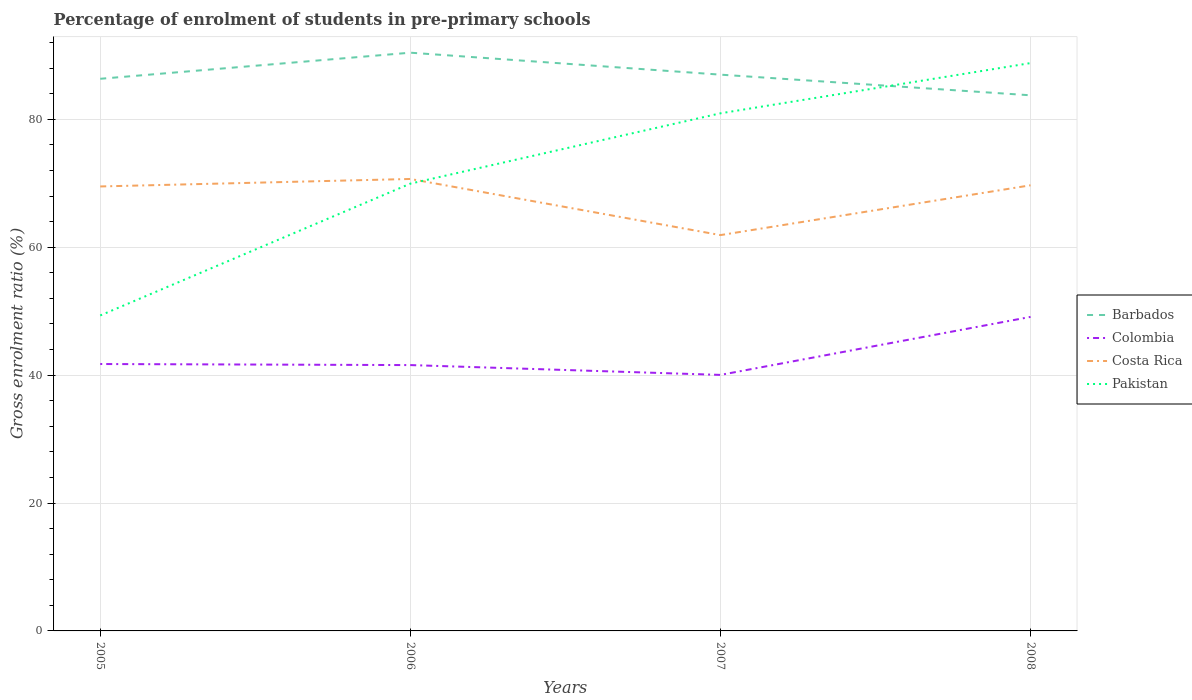Does the line corresponding to Barbados intersect with the line corresponding to Colombia?
Your answer should be compact. No. Across all years, what is the maximum percentage of students enrolled in pre-primary schools in Pakistan?
Ensure brevity in your answer.  49.33. In which year was the percentage of students enrolled in pre-primary schools in Barbados maximum?
Offer a very short reply. 2008. What is the total percentage of students enrolled in pre-primary schools in Costa Rica in the graph?
Offer a very short reply. 0.99. What is the difference between the highest and the second highest percentage of students enrolled in pre-primary schools in Costa Rica?
Offer a very short reply. 8.78. How many lines are there?
Give a very brief answer. 4. How many years are there in the graph?
Provide a short and direct response. 4. Does the graph contain any zero values?
Ensure brevity in your answer.  No. How many legend labels are there?
Provide a short and direct response. 4. How are the legend labels stacked?
Your answer should be compact. Vertical. What is the title of the graph?
Your response must be concise. Percentage of enrolment of students in pre-primary schools. What is the label or title of the X-axis?
Keep it short and to the point. Years. What is the label or title of the Y-axis?
Offer a terse response. Gross enrolment ratio (%). What is the Gross enrolment ratio (%) in Barbados in 2005?
Your answer should be compact. 86.34. What is the Gross enrolment ratio (%) of Colombia in 2005?
Make the answer very short. 41.74. What is the Gross enrolment ratio (%) in Costa Rica in 2005?
Make the answer very short. 69.51. What is the Gross enrolment ratio (%) in Pakistan in 2005?
Make the answer very short. 49.33. What is the Gross enrolment ratio (%) in Barbados in 2006?
Make the answer very short. 90.42. What is the Gross enrolment ratio (%) in Colombia in 2006?
Offer a very short reply. 41.57. What is the Gross enrolment ratio (%) of Costa Rica in 2006?
Offer a terse response. 70.68. What is the Gross enrolment ratio (%) in Pakistan in 2006?
Keep it short and to the point. 69.95. What is the Gross enrolment ratio (%) in Barbados in 2007?
Offer a terse response. 86.99. What is the Gross enrolment ratio (%) in Colombia in 2007?
Ensure brevity in your answer.  40.04. What is the Gross enrolment ratio (%) of Costa Rica in 2007?
Your answer should be compact. 61.9. What is the Gross enrolment ratio (%) of Pakistan in 2007?
Offer a very short reply. 80.94. What is the Gross enrolment ratio (%) in Barbados in 2008?
Offer a very short reply. 83.76. What is the Gross enrolment ratio (%) of Colombia in 2008?
Give a very brief answer. 49.11. What is the Gross enrolment ratio (%) in Costa Rica in 2008?
Offer a terse response. 69.69. What is the Gross enrolment ratio (%) of Pakistan in 2008?
Keep it short and to the point. 88.8. Across all years, what is the maximum Gross enrolment ratio (%) in Barbados?
Offer a very short reply. 90.42. Across all years, what is the maximum Gross enrolment ratio (%) of Colombia?
Your response must be concise. 49.11. Across all years, what is the maximum Gross enrolment ratio (%) of Costa Rica?
Make the answer very short. 70.68. Across all years, what is the maximum Gross enrolment ratio (%) of Pakistan?
Offer a very short reply. 88.8. Across all years, what is the minimum Gross enrolment ratio (%) of Barbados?
Ensure brevity in your answer.  83.76. Across all years, what is the minimum Gross enrolment ratio (%) of Colombia?
Your answer should be very brief. 40.04. Across all years, what is the minimum Gross enrolment ratio (%) in Costa Rica?
Give a very brief answer. 61.9. Across all years, what is the minimum Gross enrolment ratio (%) of Pakistan?
Give a very brief answer. 49.33. What is the total Gross enrolment ratio (%) in Barbados in the graph?
Keep it short and to the point. 347.51. What is the total Gross enrolment ratio (%) of Colombia in the graph?
Your response must be concise. 172.45. What is the total Gross enrolment ratio (%) in Costa Rica in the graph?
Offer a terse response. 271.77. What is the total Gross enrolment ratio (%) of Pakistan in the graph?
Provide a short and direct response. 289.02. What is the difference between the Gross enrolment ratio (%) of Barbados in 2005 and that in 2006?
Your answer should be very brief. -4.08. What is the difference between the Gross enrolment ratio (%) of Colombia in 2005 and that in 2006?
Keep it short and to the point. 0.17. What is the difference between the Gross enrolment ratio (%) of Costa Rica in 2005 and that in 2006?
Keep it short and to the point. -1.17. What is the difference between the Gross enrolment ratio (%) in Pakistan in 2005 and that in 2006?
Your response must be concise. -20.62. What is the difference between the Gross enrolment ratio (%) of Barbados in 2005 and that in 2007?
Offer a very short reply. -0.65. What is the difference between the Gross enrolment ratio (%) in Colombia in 2005 and that in 2007?
Give a very brief answer. 1.7. What is the difference between the Gross enrolment ratio (%) in Costa Rica in 2005 and that in 2007?
Give a very brief answer. 7.61. What is the difference between the Gross enrolment ratio (%) of Pakistan in 2005 and that in 2007?
Offer a terse response. -31.61. What is the difference between the Gross enrolment ratio (%) of Barbados in 2005 and that in 2008?
Ensure brevity in your answer.  2.58. What is the difference between the Gross enrolment ratio (%) in Colombia in 2005 and that in 2008?
Ensure brevity in your answer.  -7.37. What is the difference between the Gross enrolment ratio (%) in Costa Rica in 2005 and that in 2008?
Provide a succinct answer. -0.18. What is the difference between the Gross enrolment ratio (%) of Pakistan in 2005 and that in 2008?
Offer a very short reply. -39.47. What is the difference between the Gross enrolment ratio (%) in Barbados in 2006 and that in 2007?
Make the answer very short. 3.43. What is the difference between the Gross enrolment ratio (%) of Colombia in 2006 and that in 2007?
Provide a short and direct response. 1.54. What is the difference between the Gross enrolment ratio (%) of Costa Rica in 2006 and that in 2007?
Your response must be concise. 8.78. What is the difference between the Gross enrolment ratio (%) in Pakistan in 2006 and that in 2007?
Give a very brief answer. -11. What is the difference between the Gross enrolment ratio (%) of Barbados in 2006 and that in 2008?
Make the answer very short. 6.66. What is the difference between the Gross enrolment ratio (%) in Colombia in 2006 and that in 2008?
Provide a succinct answer. -7.54. What is the difference between the Gross enrolment ratio (%) of Costa Rica in 2006 and that in 2008?
Your answer should be very brief. 0.99. What is the difference between the Gross enrolment ratio (%) in Pakistan in 2006 and that in 2008?
Give a very brief answer. -18.85. What is the difference between the Gross enrolment ratio (%) in Barbados in 2007 and that in 2008?
Give a very brief answer. 3.23. What is the difference between the Gross enrolment ratio (%) in Colombia in 2007 and that in 2008?
Your answer should be very brief. -9.07. What is the difference between the Gross enrolment ratio (%) in Costa Rica in 2007 and that in 2008?
Make the answer very short. -7.79. What is the difference between the Gross enrolment ratio (%) in Pakistan in 2007 and that in 2008?
Your answer should be very brief. -7.86. What is the difference between the Gross enrolment ratio (%) in Barbados in 2005 and the Gross enrolment ratio (%) in Colombia in 2006?
Provide a short and direct response. 44.77. What is the difference between the Gross enrolment ratio (%) of Barbados in 2005 and the Gross enrolment ratio (%) of Costa Rica in 2006?
Offer a terse response. 15.67. What is the difference between the Gross enrolment ratio (%) in Barbados in 2005 and the Gross enrolment ratio (%) in Pakistan in 2006?
Offer a very short reply. 16.4. What is the difference between the Gross enrolment ratio (%) in Colombia in 2005 and the Gross enrolment ratio (%) in Costa Rica in 2006?
Offer a terse response. -28.94. What is the difference between the Gross enrolment ratio (%) in Colombia in 2005 and the Gross enrolment ratio (%) in Pakistan in 2006?
Make the answer very short. -28.21. What is the difference between the Gross enrolment ratio (%) of Costa Rica in 2005 and the Gross enrolment ratio (%) of Pakistan in 2006?
Your answer should be compact. -0.44. What is the difference between the Gross enrolment ratio (%) in Barbados in 2005 and the Gross enrolment ratio (%) in Colombia in 2007?
Provide a succinct answer. 46.31. What is the difference between the Gross enrolment ratio (%) in Barbados in 2005 and the Gross enrolment ratio (%) in Costa Rica in 2007?
Provide a short and direct response. 24.44. What is the difference between the Gross enrolment ratio (%) of Barbados in 2005 and the Gross enrolment ratio (%) of Pakistan in 2007?
Your answer should be very brief. 5.4. What is the difference between the Gross enrolment ratio (%) in Colombia in 2005 and the Gross enrolment ratio (%) in Costa Rica in 2007?
Offer a terse response. -20.16. What is the difference between the Gross enrolment ratio (%) in Colombia in 2005 and the Gross enrolment ratio (%) in Pakistan in 2007?
Offer a very short reply. -39.2. What is the difference between the Gross enrolment ratio (%) in Costa Rica in 2005 and the Gross enrolment ratio (%) in Pakistan in 2007?
Ensure brevity in your answer.  -11.44. What is the difference between the Gross enrolment ratio (%) in Barbados in 2005 and the Gross enrolment ratio (%) in Colombia in 2008?
Your response must be concise. 37.24. What is the difference between the Gross enrolment ratio (%) in Barbados in 2005 and the Gross enrolment ratio (%) in Costa Rica in 2008?
Your answer should be very brief. 16.65. What is the difference between the Gross enrolment ratio (%) of Barbados in 2005 and the Gross enrolment ratio (%) of Pakistan in 2008?
Keep it short and to the point. -2.46. What is the difference between the Gross enrolment ratio (%) of Colombia in 2005 and the Gross enrolment ratio (%) of Costa Rica in 2008?
Offer a terse response. -27.95. What is the difference between the Gross enrolment ratio (%) in Colombia in 2005 and the Gross enrolment ratio (%) in Pakistan in 2008?
Offer a very short reply. -47.06. What is the difference between the Gross enrolment ratio (%) of Costa Rica in 2005 and the Gross enrolment ratio (%) of Pakistan in 2008?
Your response must be concise. -19.29. What is the difference between the Gross enrolment ratio (%) in Barbados in 2006 and the Gross enrolment ratio (%) in Colombia in 2007?
Offer a terse response. 50.39. What is the difference between the Gross enrolment ratio (%) in Barbados in 2006 and the Gross enrolment ratio (%) in Costa Rica in 2007?
Keep it short and to the point. 28.52. What is the difference between the Gross enrolment ratio (%) of Barbados in 2006 and the Gross enrolment ratio (%) of Pakistan in 2007?
Offer a terse response. 9.48. What is the difference between the Gross enrolment ratio (%) in Colombia in 2006 and the Gross enrolment ratio (%) in Costa Rica in 2007?
Keep it short and to the point. -20.33. What is the difference between the Gross enrolment ratio (%) of Colombia in 2006 and the Gross enrolment ratio (%) of Pakistan in 2007?
Provide a succinct answer. -39.37. What is the difference between the Gross enrolment ratio (%) in Costa Rica in 2006 and the Gross enrolment ratio (%) in Pakistan in 2007?
Provide a succinct answer. -10.27. What is the difference between the Gross enrolment ratio (%) of Barbados in 2006 and the Gross enrolment ratio (%) of Colombia in 2008?
Provide a short and direct response. 41.32. What is the difference between the Gross enrolment ratio (%) in Barbados in 2006 and the Gross enrolment ratio (%) in Costa Rica in 2008?
Give a very brief answer. 20.74. What is the difference between the Gross enrolment ratio (%) in Barbados in 2006 and the Gross enrolment ratio (%) in Pakistan in 2008?
Your answer should be very brief. 1.63. What is the difference between the Gross enrolment ratio (%) of Colombia in 2006 and the Gross enrolment ratio (%) of Costa Rica in 2008?
Your answer should be compact. -28.12. What is the difference between the Gross enrolment ratio (%) of Colombia in 2006 and the Gross enrolment ratio (%) of Pakistan in 2008?
Your answer should be compact. -47.23. What is the difference between the Gross enrolment ratio (%) in Costa Rica in 2006 and the Gross enrolment ratio (%) in Pakistan in 2008?
Your answer should be compact. -18.12. What is the difference between the Gross enrolment ratio (%) in Barbados in 2007 and the Gross enrolment ratio (%) in Colombia in 2008?
Provide a succinct answer. 37.88. What is the difference between the Gross enrolment ratio (%) in Barbados in 2007 and the Gross enrolment ratio (%) in Costa Rica in 2008?
Your answer should be compact. 17.3. What is the difference between the Gross enrolment ratio (%) of Barbados in 2007 and the Gross enrolment ratio (%) of Pakistan in 2008?
Your answer should be compact. -1.81. What is the difference between the Gross enrolment ratio (%) in Colombia in 2007 and the Gross enrolment ratio (%) in Costa Rica in 2008?
Keep it short and to the point. -29.65. What is the difference between the Gross enrolment ratio (%) in Colombia in 2007 and the Gross enrolment ratio (%) in Pakistan in 2008?
Your answer should be compact. -48.76. What is the difference between the Gross enrolment ratio (%) of Costa Rica in 2007 and the Gross enrolment ratio (%) of Pakistan in 2008?
Provide a succinct answer. -26.9. What is the average Gross enrolment ratio (%) in Barbados per year?
Provide a succinct answer. 86.88. What is the average Gross enrolment ratio (%) in Colombia per year?
Your answer should be very brief. 43.11. What is the average Gross enrolment ratio (%) of Costa Rica per year?
Your response must be concise. 67.94. What is the average Gross enrolment ratio (%) in Pakistan per year?
Provide a short and direct response. 72.25. In the year 2005, what is the difference between the Gross enrolment ratio (%) in Barbados and Gross enrolment ratio (%) in Colombia?
Make the answer very short. 44.6. In the year 2005, what is the difference between the Gross enrolment ratio (%) of Barbados and Gross enrolment ratio (%) of Costa Rica?
Your answer should be very brief. 16.84. In the year 2005, what is the difference between the Gross enrolment ratio (%) of Barbados and Gross enrolment ratio (%) of Pakistan?
Offer a very short reply. 37.01. In the year 2005, what is the difference between the Gross enrolment ratio (%) in Colombia and Gross enrolment ratio (%) in Costa Rica?
Keep it short and to the point. -27.77. In the year 2005, what is the difference between the Gross enrolment ratio (%) of Colombia and Gross enrolment ratio (%) of Pakistan?
Ensure brevity in your answer.  -7.59. In the year 2005, what is the difference between the Gross enrolment ratio (%) in Costa Rica and Gross enrolment ratio (%) in Pakistan?
Give a very brief answer. 20.18. In the year 2006, what is the difference between the Gross enrolment ratio (%) of Barbados and Gross enrolment ratio (%) of Colombia?
Provide a short and direct response. 48.85. In the year 2006, what is the difference between the Gross enrolment ratio (%) of Barbados and Gross enrolment ratio (%) of Costa Rica?
Keep it short and to the point. 19.75. In the year 2006, what is the difference between the Gross enrolment ratio (%) of Barbados and Gross enrolment ratio (%) of Pakistan?
Your answer should be compact. 20.48. In the year 2006, what is the difference between the Gross enrolment ratio (%) in Colombia and Gross enrolment ratio (%) in Costa Rica?
Offer a very short reply. -29.1. In the year 2006, what is the difference between the Gross enrolment ratio (%) in Colombia and Gross enrolment ratio (%) in Pakistan?
Give a very brief answer. -28.37. In the year 2006, what is the difference between the Gross enrolment ratio (%) of Costa Rica and Gross enrolment ratio (%) of Pakistan?
Provide a succinct answer. 0.73. In the year 2007, what is the difference between the Gross enrolment ratio (%) in Barbados and Gross enrolment ratio (%) in Colombia?
Offer a very short reply. 46.95. In the year 2007, what is the difference between the Gross enrolment ratio (%) of Barbados and Gross enrolment ratio (%) of Costa Rica?
Offer a terse response. 25.09. In the year 2007, what is the difference between the Gross enrolment ratio (%) of Barbados and Gross enrolment ratio (%) of Pakistan?
Ensure brevity in your answer.  6.05. In the year 2007, what is the difference between the Gross enrolment ratio (%) of Colombia and Gross enrolment ratio (%) of Costa Rica?
Your response must be concise. -21.86. In the year 2007, what is the difference between the Gross enrolment ratio (%) of Colombia and Gross enrolment ratio (%) of Pakistan?
Your answer should be very brief. -40.91. In the year 2007, what is the difference between the Gross enrolment ratio (%) of Costa Rica and Gross enrolment ratio (%) of Pakistan?
Offer a very short reply. -19.04. In the year 2008, what is the difference between the Gross enrolment ratio (%) in Barbados and Gross enrolment ratio (%) in Colombia?
Offer a terse response. 34.65. In the year 2008, what is the difference between the Gross enrolment ratio (%) in Barbados and Gross enrolment ratio (%) in Costa Rica?
Make the answer very short. 14.07. In the year 2008, what is the difference between the Gross enrolment ratio (%) in Barbados and Gross enrolment ratio (%) in Pakistan?
Provide a succinct answer. -5.04. In the year 2008, what is the difference between the Gross enrolment ratio (%) in Colombia and Gross enrolment ratio (%) in Costa Rica?
Give a very brief answer. -20.58. In the year 2008, what is the difference between the Gross enrolment ratio (%) in Colombia and Gross enrolment ratio (%) in Pakistan?
Keep it short and to the point. -39.69. In the year 2008, what is the difference between the Gross enrolment ratio (%) in Costa Rica and Gross enrolment ratio (%) in Pakistan?
Give a very brief answer. -19.11. What is the ratio of the Gross enrolment ratio (%) of Barbados in 2005 to that in 2006?
Your answer should be compact. 0.95. What is the ratio of the Gross enrolment ratio (%) in Costa Rica in 2005 to that in 2006?
Your answer should be compact. 0.98. What is the ratio of the Gross enrolment ratio (%) of Pakistan in 2005 to that in 2006?
Ensure brevity in your answer.  0.71. What is the ratio of the Gross enrolment ratio (%) in Barbados in 2005 to that in 2007?
Provide a succinct answer. 0.99. What is the ratio of the Gross enrolment ratio (%) in Colombia in 2005 to that in 2007?
Offer a terse response. 1.04. What is the ratio of the Gross enrolment ratio (%) in Costa Rica in 2005 to that in 2007?
Your answer should be compact. 1.12. What is the ratio of the Gross enrolment ratio (%) of Pakistan in 2005 to that in 2007?
Your answer should be very brief. 0.61. What is the ratio of the Gross enrolment ratio (%) of Barbados in 2005 to that in 2008?
Provide a short and direct response. 1.03. What is the ratio of the Gross enrolment ratio (%) of Colombia in 2005 to that in 2008?
Your response must be concise. 0.85. What is the ratio of the Gross enrolment ratio (%) of Costa Rica in 2005 to that in 2008?
Your response must be concise. 1. What is the ratio of the Gross enrolment ratio (%) of Pakistan in 2005 to that in 2008?
Provide a succinct answer. 0.56. What is the ratio of the Gross enrolment ratio (%) of Barbados in 2006 to that in 2007?
Your response must be concise. 1.04. What is the ratio of the Gross enrolment ratio (%) of Colombia in 2006 to that in 2007?
Provide a short and direct response. 1.04. What is the ratio of the Gross enrolment ratio (%) of Costa Rica in 2006 to that in 2007?
Your answer should be compact. 1.14. What is the ratio of the Gross enrolment ratio (%) in Pakistan in 2006 to that in 2007?
Make the answer very short. 0.86. What is the ratio of the Gross enrolment ratio (%) of Barbados in 2006 to that in 2008?
Provide a short and direct response. 1.08. What is the ratio of the Gross enrolment ratio (%) of Colombia in 2006 to that in 2008?
Make the answer very short. 0.85. What is the ratio of the Gross enrolment ratio (%) of Costa Rica in 2006 to that in 2008?
Keep it short and to the point. 1.01. What is the ratio of the Gross enrolment ratio (%) of Pakistan in 2006 to that in 2008?
Provide a succinct answer. 0.79. What is the ratio of the Gross enrolment ratio (%) in Barbados in 2007 to that in 2008?
Give a very brief answer. 1.04. What is the ratio of the Gross enrolment ratio (%) in Colombia in 2007 to that in 2008?
Keep it short and to the point. 0.82. What is the ratio of the Gross enrolment ratio (%) in Costa Rica in 2007 to that in 2008?
Keep it short and to the point. 0.89. What is the ratio of the Gross enrolment ratio (%) of Pakistan in 2007 to that in 2008?
Your answer should be very brief. 0.91. What is the difference between the highest and the second highest Gross enrolment ratio (%) in Barbados?
Provide a succinct answer. 3.43. What is the difference between the highest and the second highest Gross enrolment ratio (%) of Colombia?
Your response must be concise. 7.37. What is the difference between the highest and the second highest Gross enrolment ratio (%) in Costa Rica?
Provide a short and direct response. 0.99. What is the difference between the highest and the second highest Gross enrolment ratio (%) of Pakistan?
Give a very brief answer. 7.86. What is the difference between the highest and the lowest Gross enrolment ratio (%) of Barbados?
Your response must be concise. 6.66. What is the difference between the highest and the lowest Gross enrolment ratio (%) in Colombia?
Offer a terse response. 9.07. What is the difference between the highest and the lowest Gross enrolment ratio (%) of Costa Rica?
Make the answer very short. 8.78. What is the difference between the highest and the lowest Gross enrolment ratio (%) of Pakistan?
Ensure brevity in your answer.  39.47. 